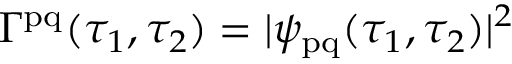Convert formula to latex. <formula><loc_0><loc_0><loc_500><loc_500>\Gamma ^ { p q } ( \tau _ { 1 } , \tau _ { 2 } ) = | \psi _ { p q } ( \tau _ { 1 } , \tau _ { 2 } ) | ^ { 2 }</formula> 